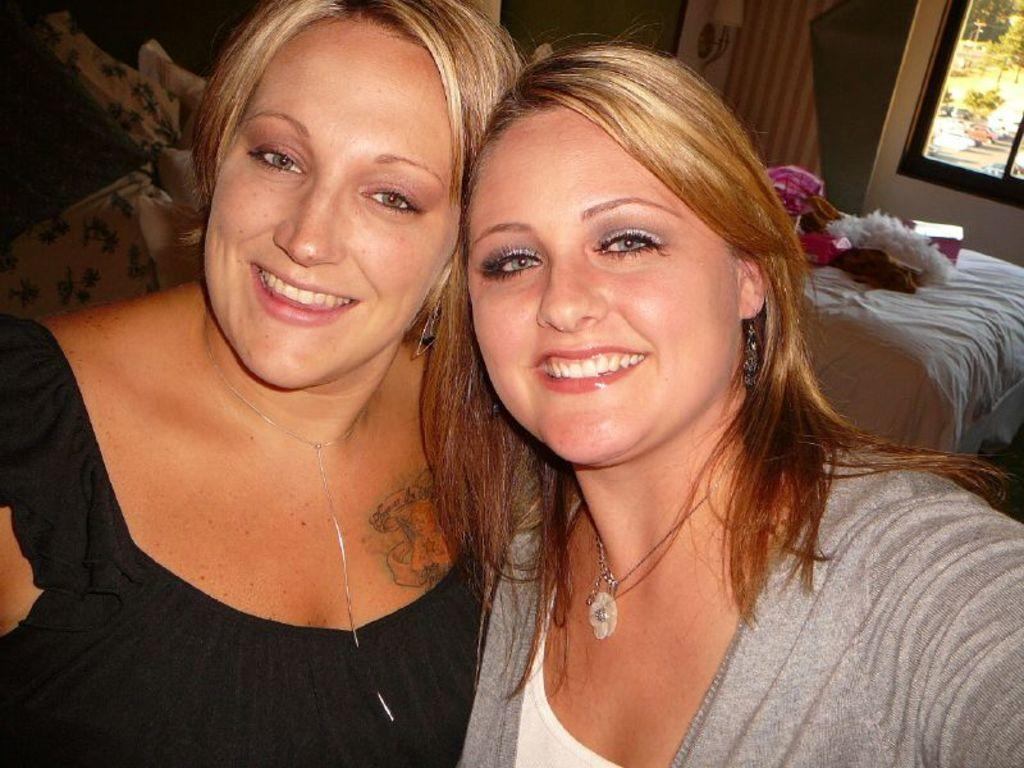How many people are in the image? There are two persons in the image. What type of furniture is present in the image? There is a sofa and a bed in the image. What is the purpose of the glass window in the image? The glass window allows for visibility of the trees outside. What can be seen through the glass window? Trees are visible behind the glass window. How many books are on the chair in the image? There is no chair or books present in the image. What type of bulb is used to light up the room in the image? There is no information about lighting in the image, so it cannot be determined what type of bulb is used. 